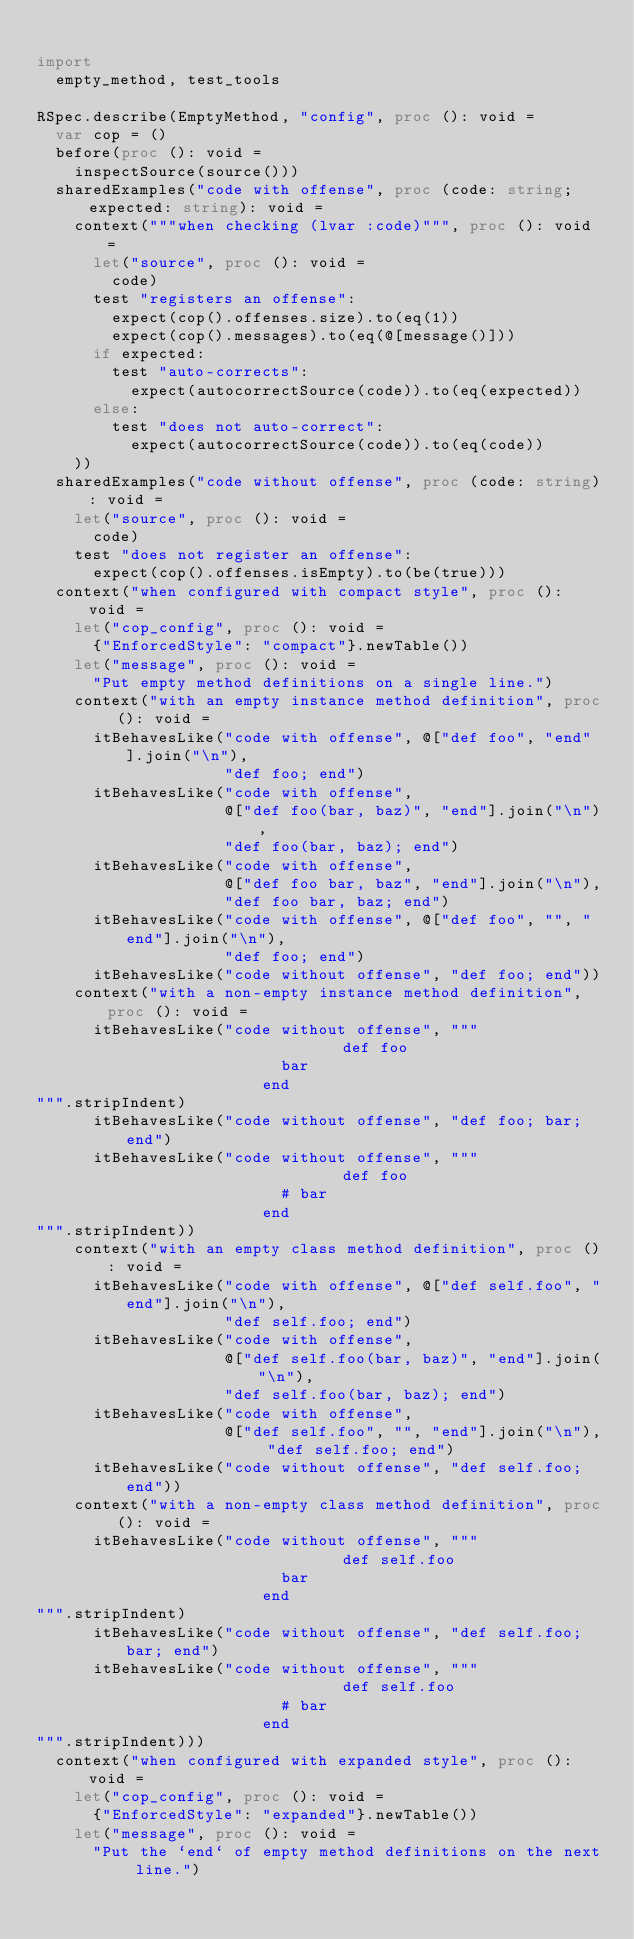Convert code to text. <code><loc_0><loc_0><loc_500><loc_500><_Nim_>
import
  empty_method, test_tools

RSpec.describe(EmptyMethod, "config", proc (): void =
  var cop = ()
  before(proc (): void =
    inspectSource(source()))
  sharedExamples("code with offense", proc (code: string; expected: string): void =
    context("""when checking (lvar :code)""", proc (): void =
      let("source", proc (): void =
        code)
      test "registers an offense":
        expect(cop().offenses.size).to(eq(1))
        expect(cop().messages).to(eq(@[message()]))
      if expected:
        test "auto-corrects":
          expect(autocorrectSource(code)).to(eq(expected))
      else:
        test "does not auto-correct":
          expect(autocorrectSource(code)).to(eq(code))
    ))
  sharedExamples("code without offense", proc (code: string): void =
    let("source", proc (): void =
      code)
    test "does not register an offense":
      expect(cop().offenses.isEmpty).to(be(true)))
  context("when configured with compact style", proc (): void =
    let("cop_config", proc (): void =
      {"EnforcedStyle": "compact"}.newTable())
    let("message", proc (): void =
      "Put empty method definitions on a single line.")
    context("with an empty instance method definition", proc (): void =
      itBehavesLike("code with offense", @["def foo", "end"].join("\n"),
                    "def foo; end")
      itBehavesLike("code with offense",
                    @["def foo(bar, baz)", "end"].join("\n"),
                    "def foo(bar, baz); end")
      itBehavesLike("code with offense",
                    @["def foo bar, baz", "end"].join("\n"),
                    "def foo bar, baz; end")
      itBehavesLike("code with offense", @["def foo", "", "end"].join("\n"),
                    "def foo; end")
      itBehavesLike("code without offense", "def foo; end"))
    context("with a non-empty instance method definition", proc (): void =
      itBehavesLike("code without offense", """                        def foo
                          bar
                        end
""".stripIndent)
      itBehavesLike("code without offense", "def foo; bar; end")
      itBehavesLike("code without offense", """                        def foo
                          # bar
                        end
""".stripIndent))
    context("with an empty class method definition", proc (): void =
      itBehavesLike("code with offense", @["def self.foo", "end"].join("\n"),
                    "def self.foo; end")
      itBehavesLike("code with offense",
                    @["def self.foo(bar, baz)", "end"].join("\n"),
                    "def self.foo(bar, baz); end")
      itBehavesLike("code with offense",
                    @["def self.foo", "", "end"].join("\n"), "def self.foo; end")
      itBehavesLike("code without offense", "def self.foo; end"))
    context("with a non-empty class method definition", proc (): void =
      itBehavesLike("code without offense", """                        def self.foo
                          bar
                        end
""".stripIndent)
      itBehavesLike("code without offense", "def self.foo; bar; end")
      itBehavesLike("code without offense", """                        def self.foo
                          # bar
                        end
""".stripIndent)))
  context("when configured with expanded style", proc (): void =
    let("cop_config", proc (): void =
      {"EnforcedStyle": "expanded"}.newTable())
    let("message", proc (): void =
      "Put the `end` of empty method definitions on the next line.")</code> 